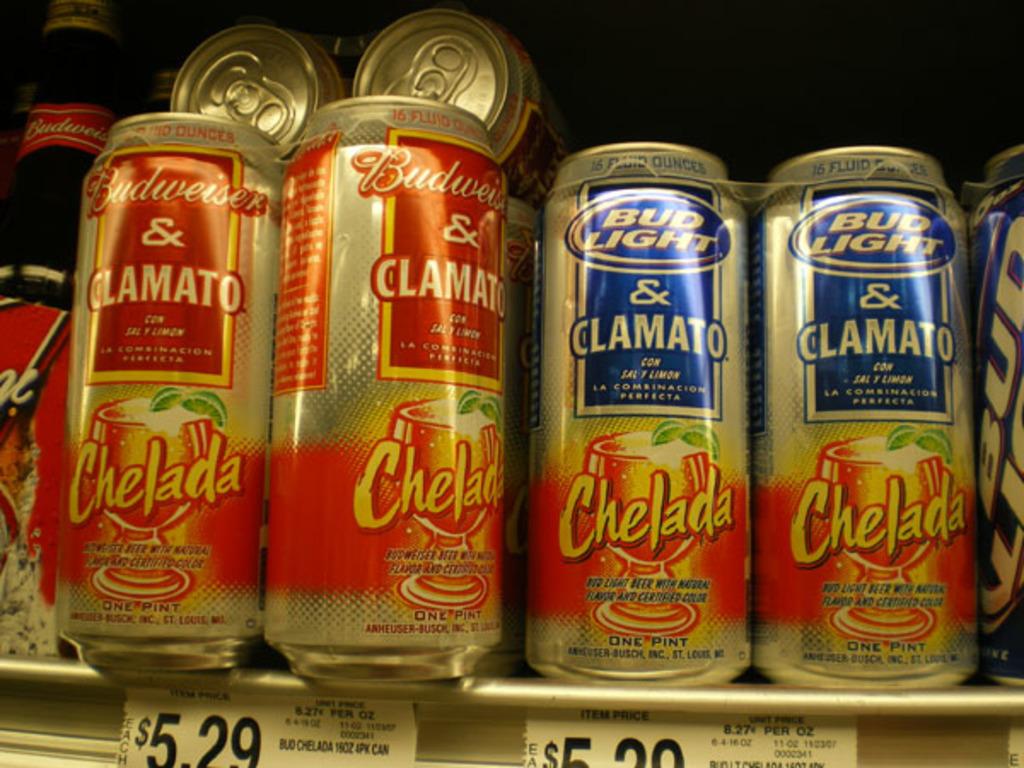What does the left price read?
Your response must be concise. 5.29. 